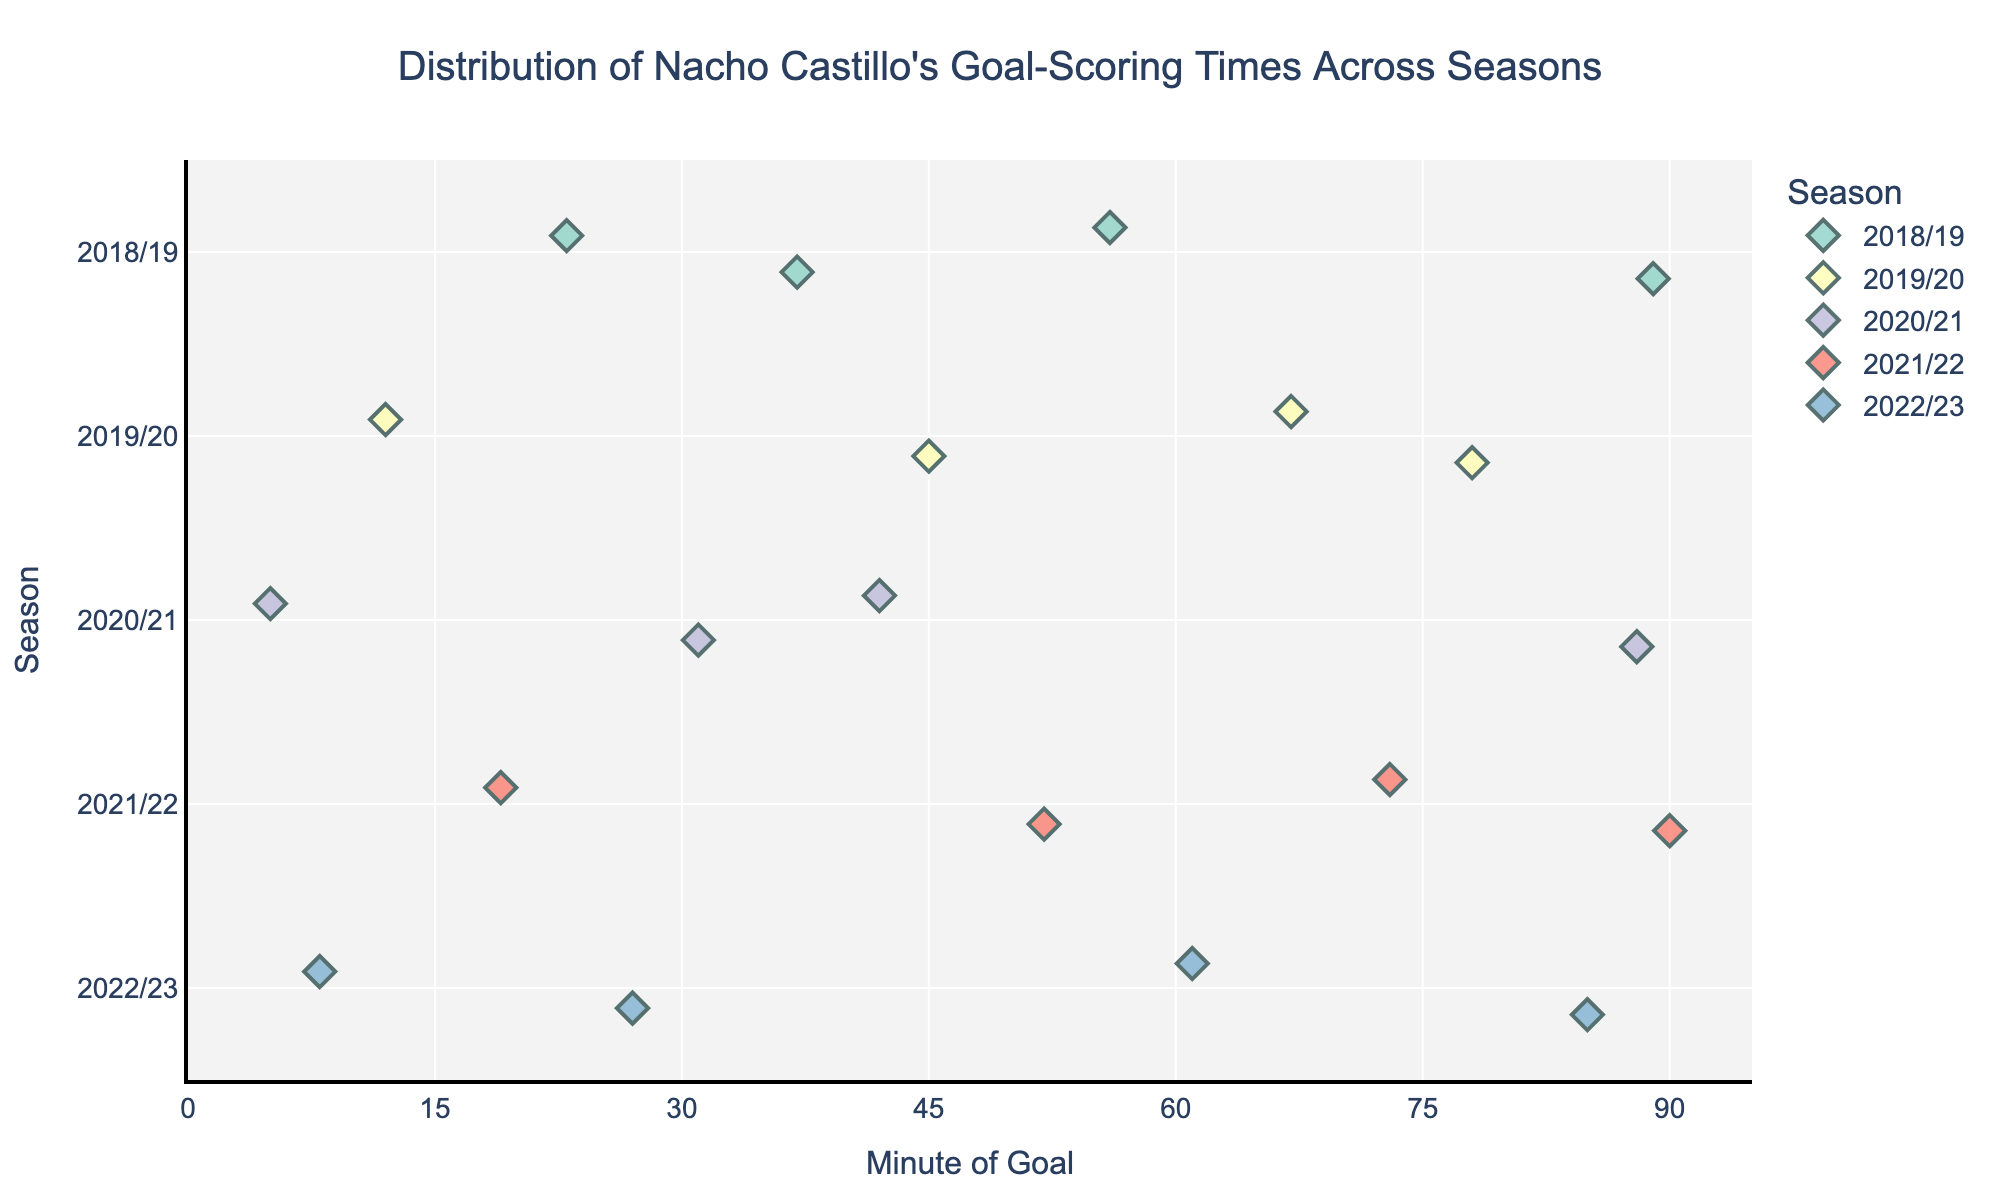What's the title of the plot? The title is typically located at the top of the plot. It provides a summary or description of what the plot represents. In this case, it states that the plot shows the distribution of Nacho Castillo's goal-scoring times across different seasons.
Answer: Distribution of Nacho Castillo's Goal-Scoring Times Across Seasons How many seasons are represented in the plot? The number of different categories (seasons) on the y-axis represents the total number of seasons. By counting the distinct categories, we get the total number of seasons.
Answer: 5 In which season did Nacho Castillo score the latest goal, and at what minute? To find the latest goal in a specific season, we look at the rightmost data point in each row. The rightmost point indicates the latest goal scored in that season and its corresponding minute.
Answer: 2021/22, 90th minute Which season had the highest number of goals scored? Counting the number of data points (markers) in each row, we can determine which season has the most points. Each data point represents a goal.
Answer: 2021/22 Which season had goals scored closest to the start of the match (0-15 minutes)? Look for data points to the leftmost part of the x-axis (near 0-15 minute range) and see which season has points within this range.
Answer: 2019/20 and 2020/21 On average, did Nacho Castillo score earlier goals in the 2018/19 season or the 2022/23 season? Calculate the average of the goal timings for each season and compare. For 2018/19: (23 + 37 + 56 + 89) / 4 = 51.25 minutes. For 2022/23: (8 + 27 + 61 + 85) / 4 = 45.25 minutes. So, by comparing these averages, we determine which season has earlier average goals.
Answer: 2022/23 Which season had more goals in the second half of the match (after the 45th minute)? Count the number of goals (data points) to the right of the 45-minute mark for each season. Check which season has more data points in this range.
Answer: 2021/22 How does the distribution of goal-scoring times in the 2020/21 season compare to that in the 2019/20 season? Examine the spread and concentration of data points across the two seasons and note any differences in the timing and distribution of the goals. The 2020/21 season has goals spread across the match with one nearing the end, while the 2019/20 season seems to have a more scattered distribution throughout.
Answer: 2020/21 has an end-of-match peak Which minute had the most goals scored across all seasons? Count the occurrence of each minute (x-axis values) across all seasons. The minute with the highest count has the most goals scored.
Answer: There is no repeat goal-minute in the given data 